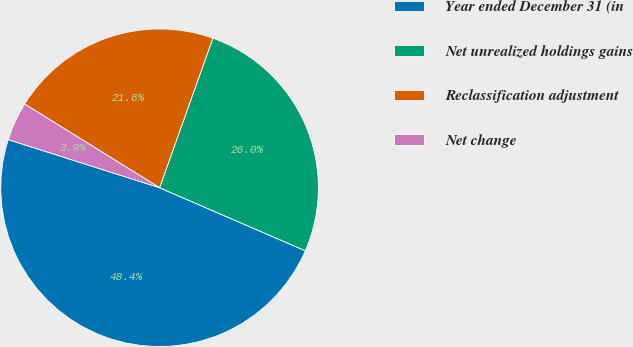Convert chart to OTSL. <chart><loc_0><loc_0><loc_500><loc_500><pie_chart><fcel>Year ended December 31 (in<fcel>Net unrealized holdings gains<fcel>Reclassification adjustment<fcel>Net change<nl><fcel>48.4%<fcel>26.05%<fcel>21.61%<fcel>3.94%<nl></chart> 